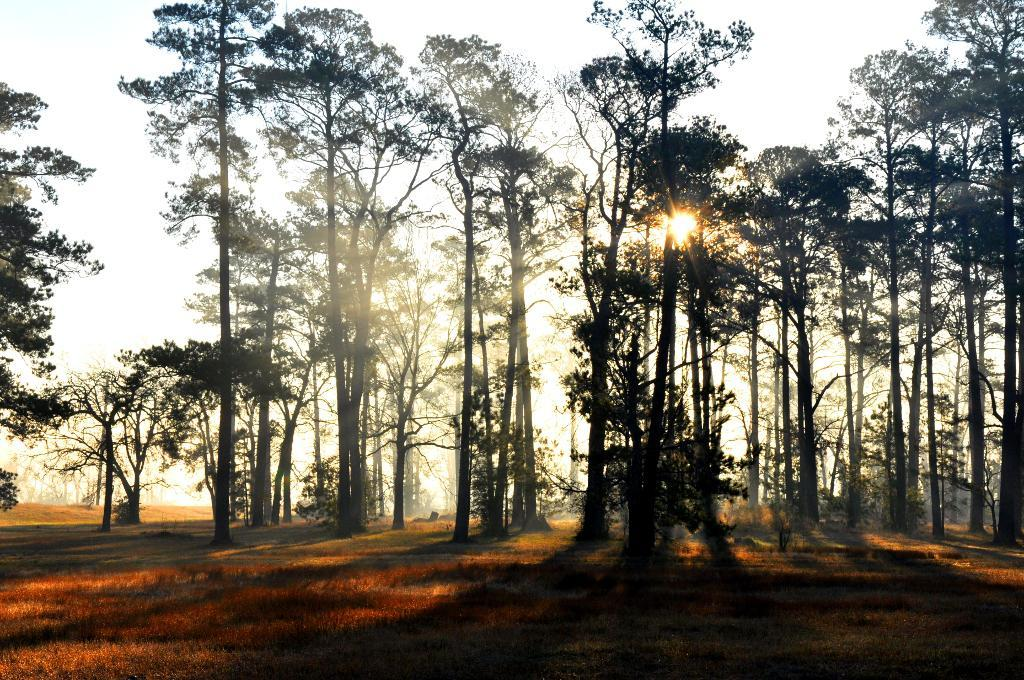What type of vegetation can be seen in the image? There are trees in the image. What else can be seen on the ground in the image? There is grass in the image. What celestial body is visible in the image? The sun is visible in the image. What else can be seen in the sky in the image? The sky is visible in the image. What type of cushion is being used to float on the ice in the image? There is no ice or cushion present in the image. 